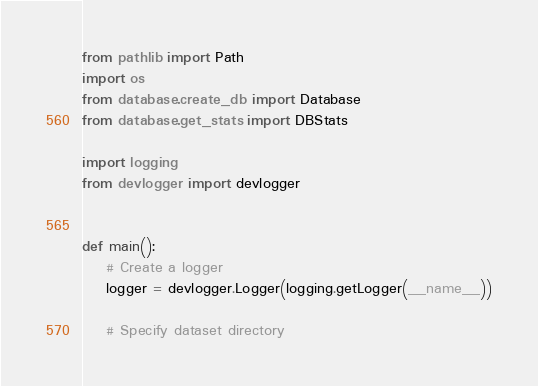<code> <loc_0><loc_0><loc_500><loc_500><_Python_>from pathlib import Path
import os
from database.create_db import Database
from database.get_stats import DBStats

import logging
from devlogger import devlogger


def main():
    # Create a logger
    logger = devlogger.Logger(logging.getLogger(__name__))

    # Specify dataset directory</code> 